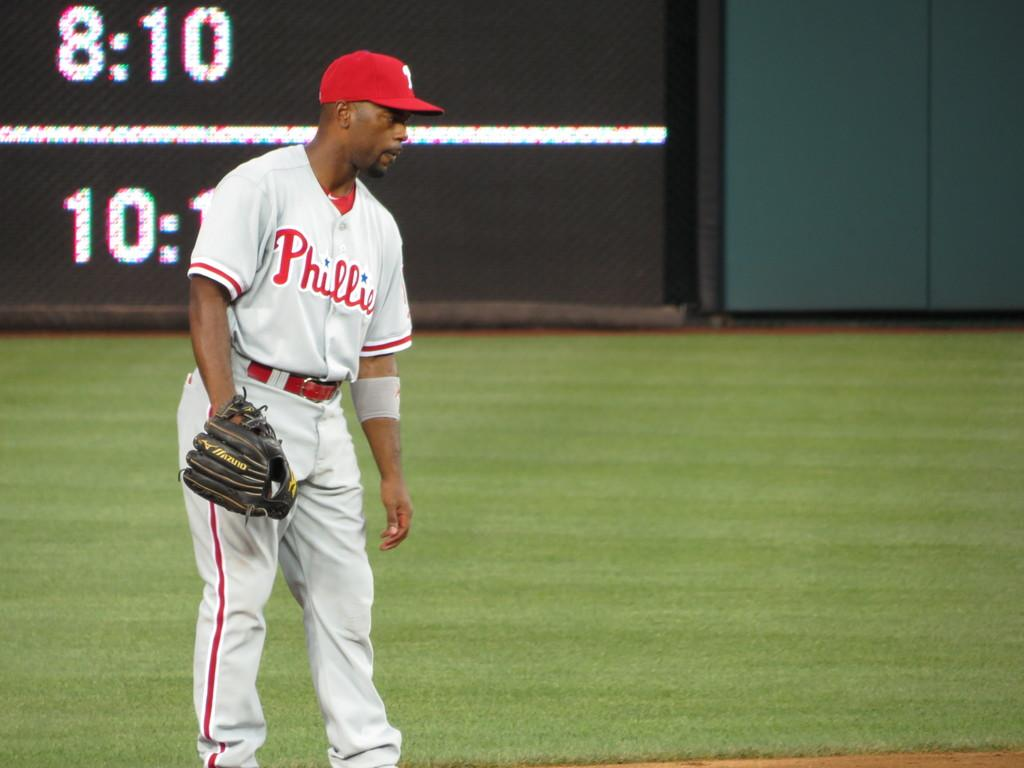<image>
Create a compact narrative representing the image presented. the time is 8:10 on a scoreboard in the outfield 